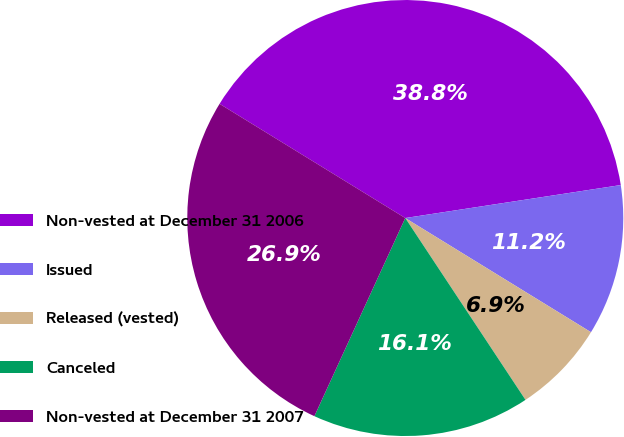Convert chart to OTSL. <chart><loc_0><loc_0><loc_500><loc_500><pie_chart><fcel>Non-vested at December 31 2006<fcel>Issued<fcel>Released (vested)<fcel>Canceled<fcel>Non-vested at December 31 2007<nl><fcel>38.81%<fcel>11.19%<fcel>6.93%<fcel>16.14%<fcel>26.93%<nl></chart> 